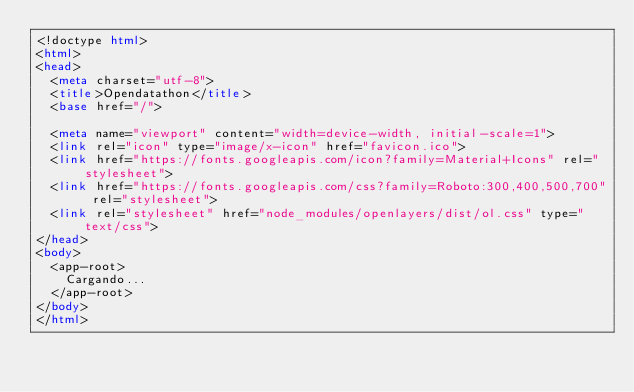Convert code to text. <code><loc_0><loc_0><loc_500><loc_500><_HTML_><!doctype html>
<html>
<head>
  <meta charset="utf-8">
  <title>Opendatathon</title>
  <base href="/">

  <meta name="viewport" content="width=device-width, initial-scale=1">
  <link rel="icon" type="image/x-icon" href="favicon.ico">
  <link href="https://fonts.googleapis.com/icon?family=Material+Icons" rel="stylesheet">
  <link href="https://fonts.googleapis.com/css?family=Roboto:300,400,500,700" rel="stylesheet">
  <link rel="stylesheet" href="node_modules/openlayers/dist/ol.css" type="text/css"> 
</head>
<body>
  <app-root>
    Cargando...
  </app-root>
</body>
</html>
</code> 